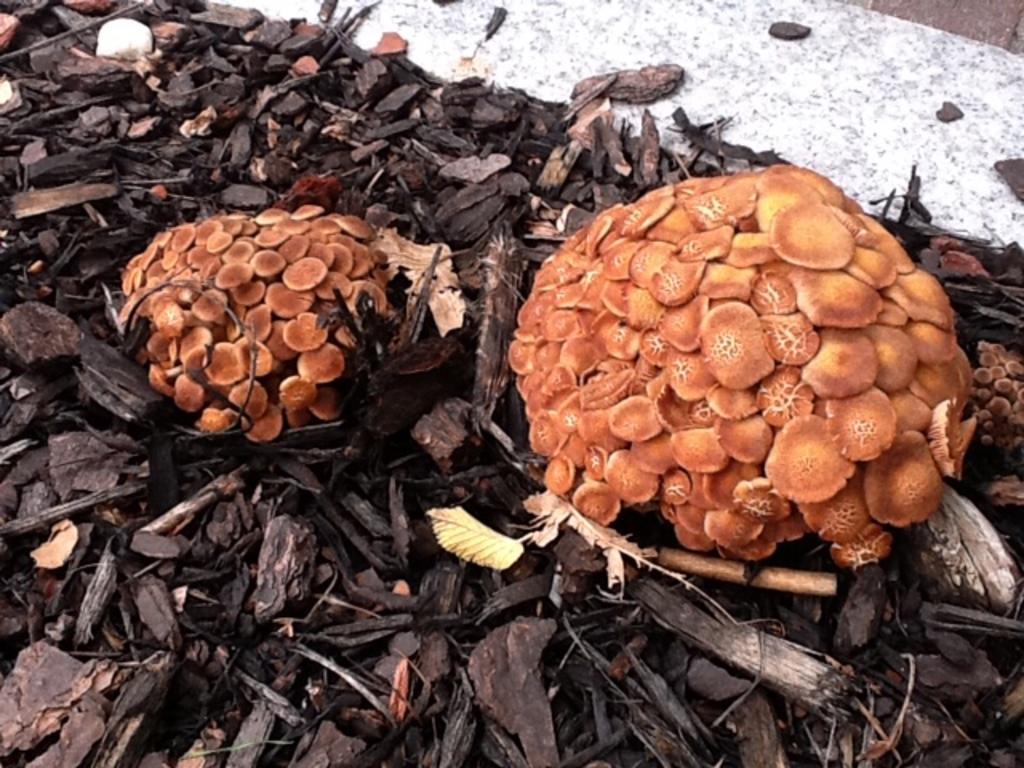What type of fungi can be seen in the image? There are mushrooms in the image. What other objects are present in the image? There are wooden sticks and dry leaves in the image. How many babies are crawling among the mushrooms in the image? There are no babies present in the image; it only features mushrooms, wooden sticks, and dry leaves. 